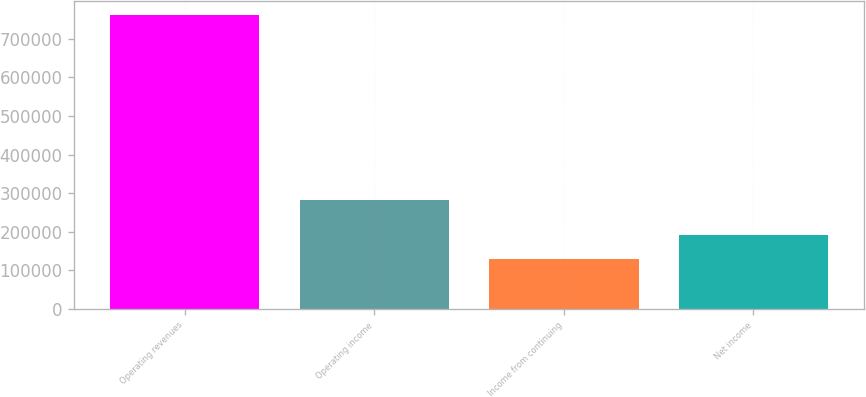Convert chart. <chart><loc_0><loc_0><loc_500><loc_500><bar_chart><fcel>Operating revenues<fcel>Operating income<fcel>Income from continuing<fcel>Net income<nl><fcel>760869<fcel>281408<fcel>128495<fcel>191732<nl></chart> 